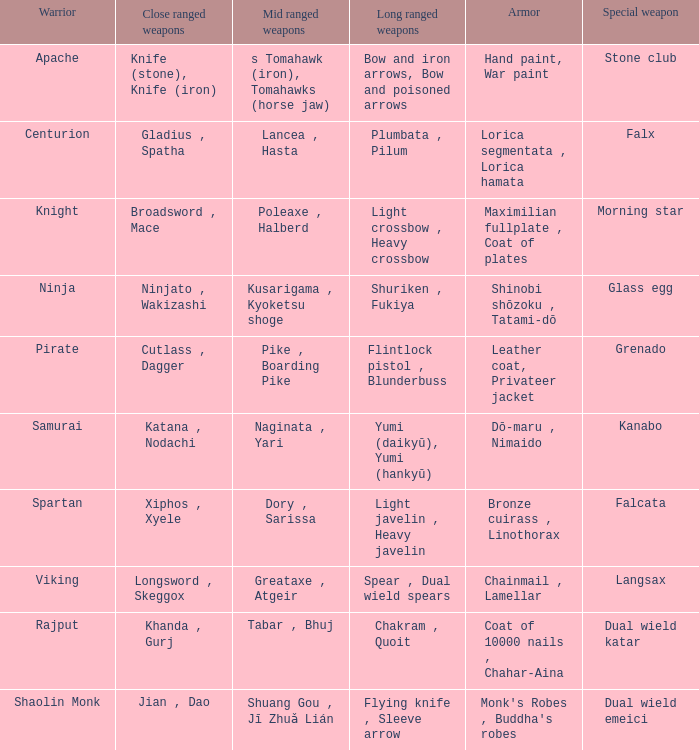If the Close ranged weapons are the knife (stone), knife (iron), what are the Long ranged weapons? Bow and iron arrows, Bow and poisoned arrows. 